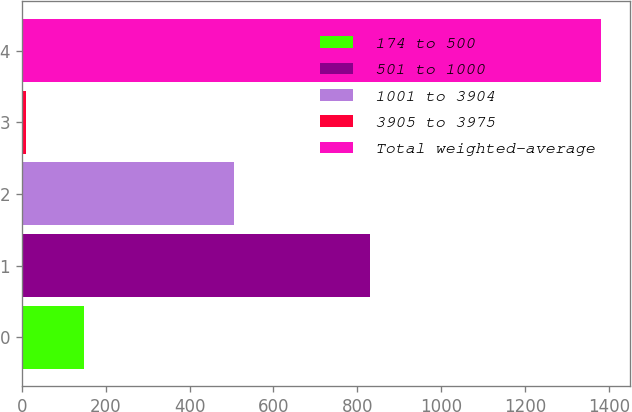<chart> <loc_0><loc_0><loc_500><loc_500><bar_chart><fcel>174 to 500<fcel>501 to 1000<fcel>1001 to 3904<fcel>3905 to 3975<fcel>Total weighted-average<nl><fcel>147.9<fcel>829<fcel>505<fcel>11<fcel>1380<nl></chart> 